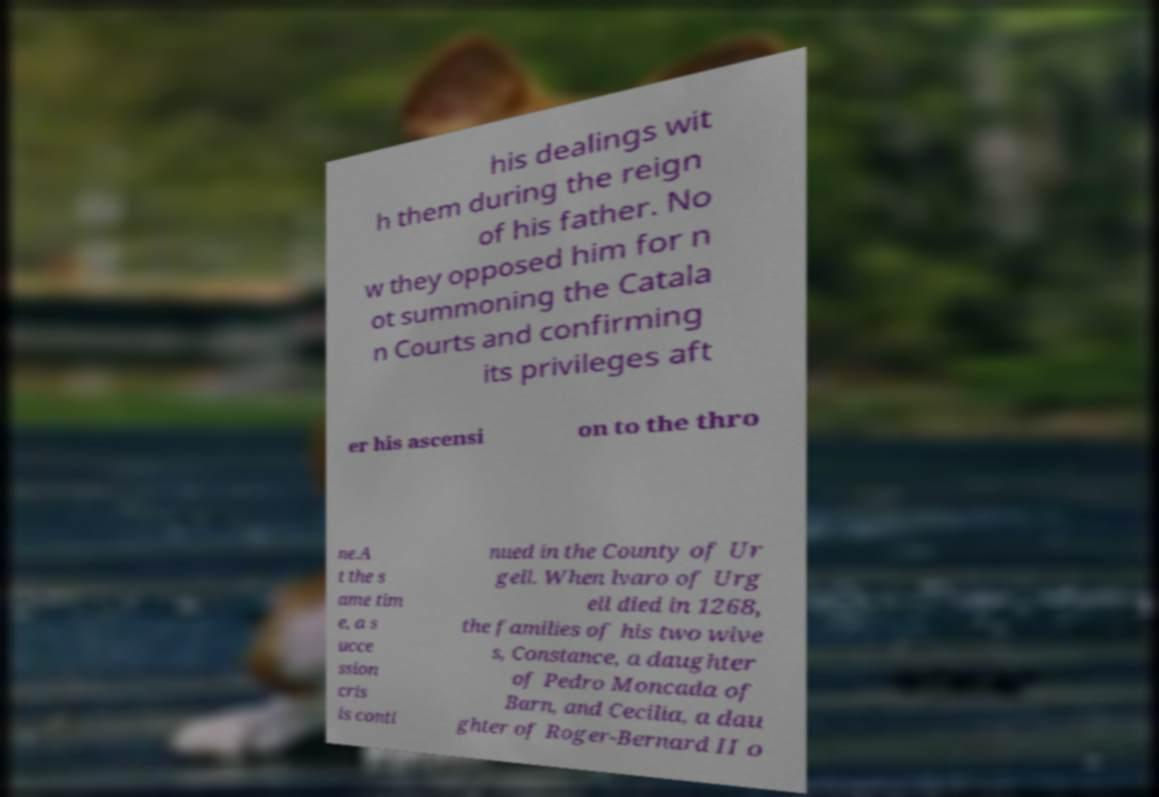Could you assist in decoding the text presented in this image and type it out clearly? his dealings wit h them during the reign of his father. No w they opposed him for n ot summoning the Catala n Courts and confirming its privileges aft er his ascensi on to the thro ne.A t the s ame tim e, a s ucce ssion cris is conti nued in the County of Ur gell. When lvaro of Urg ell died in 1268, the families of his two wive s, Constance, a daughter of Pedro Moncada of Barn, and Cecilia, a dau ghter of Roger-Bernard II o 